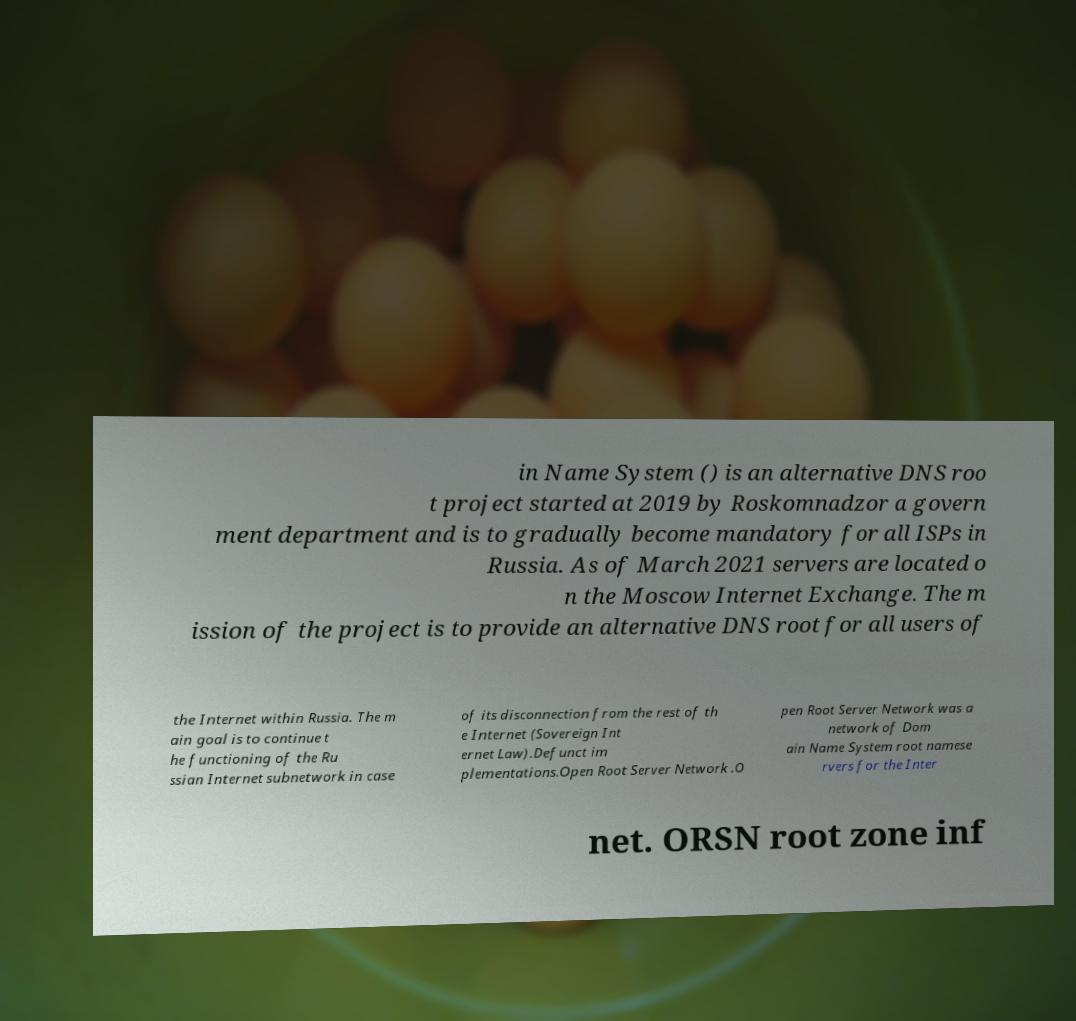For documentation purposes, I need the text within this image transcribed. Could you provide that? in Name System () is an alternative DNS roo t project started at 2019 by Roskomnadzor a govern ment department and is to gradually become mandatory for all ISPs in Russia. As of March 2021 servers are located o n the Moscow Internet Exchange. The m ission of the project is to provide an alternative DNS root for all users of the Internet within Russia. The m ain goal is to continue t he functioning of the Ru ssian Internet subnetwork in case of its disconnection from the rest of th e Internet (Sovereign Int ernet Law).Defunct im plementations.Open Root Server Network .O pen Root Server Network was a network of Dom ain Name System root namese rvers for the Inter net. ORSN root zone inf 